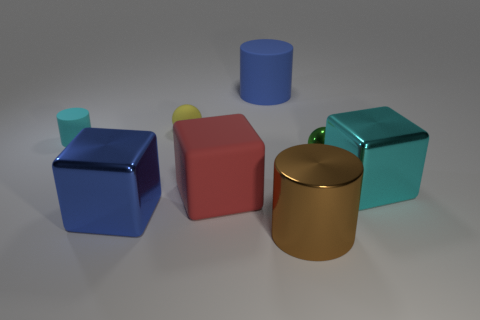Subtract all blocks. How many objects are left? 5 Subtract all small matte cylinders. How many cylinders are left? 2 Subtract 1 cyan blocks. How many objects are left? 7 Subtract 2 spheres. How many spheres are left? 0 Subtract all green balls. Subtract all green cubes. How many balls are left? 1 Subtract all purple balls. How many brown cylinders are left? 1 Subtract all large cyan metallic things. Subtract all tiny red rubber objects. How many objects are left? 7 Add 8 blue rubber cylinders. How many blue rubber cylinders are left? 9 Add 3 big cyan rubber balls. How many big cyan rubber balls exist? 3 Add 2 tiny gray spheres. How many objects exist? 10 